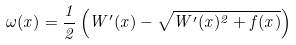Convert formula to latex. <formula><loc_0><loc_0><loc_500><loc_500>\omega ( x ) = \frac { 1 } { 2 } \left ( W ^ { \prime } ( x ) - \sqrt { W ^ { \prime } ( x ) ^ { 2 } + f ( x ) } \right )</formula> 